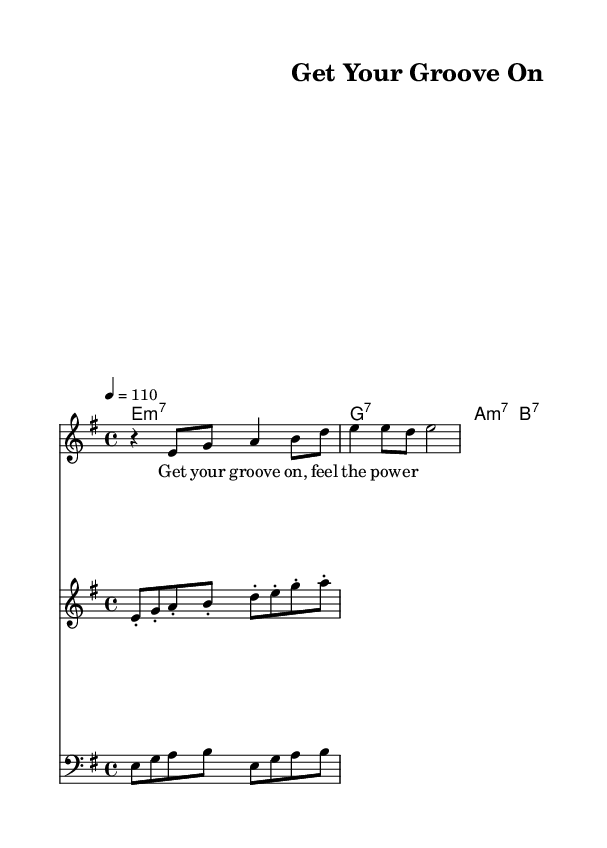What is the key signature of this music? The key signature is indicated by the sharp or flat symbols at the beginning of the staff. In this piece, the key signature has one sharp, which corresponds to the key of E minor.
Answer: E minor What is the time signature of this music? The time signature is displayed at the beginning of the piece. Here, the time signature reads 4/4, which means there are four quarter notes per measure.
Answer: 4/4 What is the tempo marking for this piece? The tempo marking is found at the start of the score, mentioning how fast to play the music. It is indicated as "4 = 110," which refers to 110 beats per minute.
Answer: 110 How many bars are in the bass riff section? To find the number of bars, we review the bass riff line and count the number of measures. The bass riff contains four measures.
Answer: 4 What chords are played in the guitar section? The chord names are notated in a specific section. The guitar section plays the chords E minor 7, G 7, A minor 7, and B 7 in a progression.
Answer: E minor 7, G 7, A minor 7, B 7 What is the primary lyrical message in the vocal section? The lyrics follow the melody notes and express a motivational theme. The primary message from the lyrics indicates empowerment with the phrase "Get your groove on, feel the power."
Answer: "feel the power." What is a characteristic element of funk in this piece? Funk music often features strong rhythmic grooves and a lively brass section, which can be identified in the score through the prominent brass hook and tight rhythms.
Answer: Brass section 